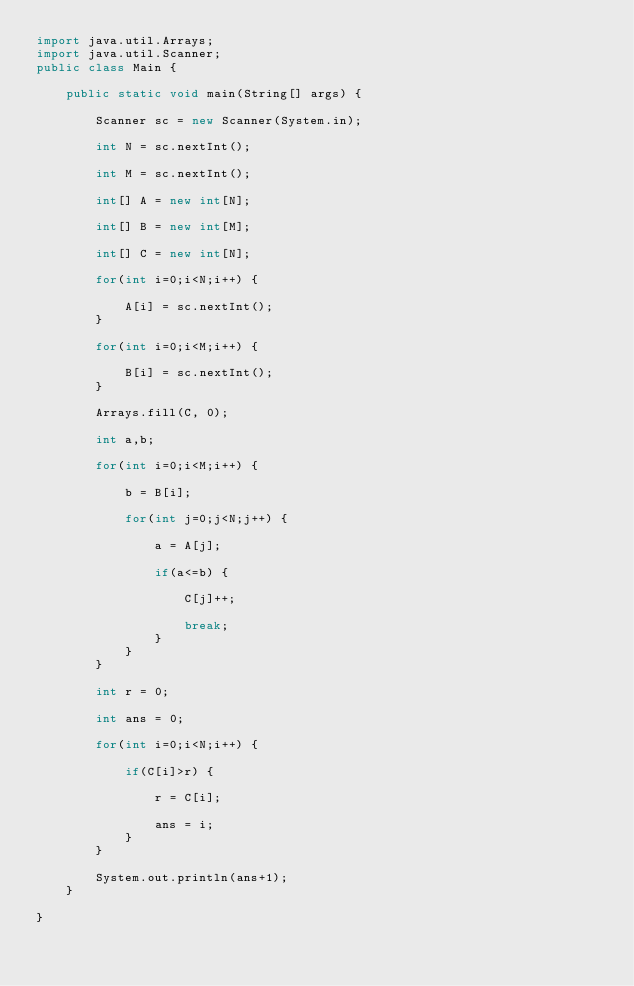Convert code to text. <code><loc_0><loc_0><loc_500><loc_500><_Java_>import java.util.Arrays;
import java.util.Scanner;
public class Main {

	public static void main(String[] args) {

		Scanner sc = new Scanner(System.in);

		int N = sc.nextInt();

		int M = sc.nextInt();

		int[] A = new int[N];

		int[] B = new int[M];

		int[] C = new int[N];

		for(int i=0;i<N;i++) {

			A[i] = sc.nextInt();
		}

		for(int i=0;i<M;i++) {

			B[i] = sc.nextInt();
		}

		Arrays.fill(C, 0);

		int a,b;

		for(int i=0;i<M;i++) {

			b = B[i];

			for(int j=0;j<N;j++) {

				a = A[j];

				if(a<=b) {

					C[j]++;

					break;
				}
			}
		}

		int r = 0;

		int ans = 0;

		for(int i=0;i<N;i++) {

			if(C[i]>r) {

				r = C[i];

				ans = i;
			}
		}

		System.out.println(ans+1);
	}

}

</code> 